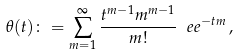<formula> <loc_0><loc_0><loc_500><loc_500>\theta ( t ) \colon = \sum _ { m = 1 } ^ { \infty } \frac { t ^ { m - 1 } m ^ { m - 1 } } { m ! } \ e e ^ { - t m } \, ,</formula> 